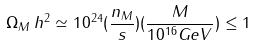Convert formula to latex. <formula><loc_0><loc_0><loc_500><loc_500>\Omega _ { M } \, h ^ { 2 } \simeq 1 0 ^ { 2 4 } ( \frac { n _ { M } } { s } ) ( \frac { M } { 1 0 ^ { 1 6 } G e V } ) \leq 1</formula> 